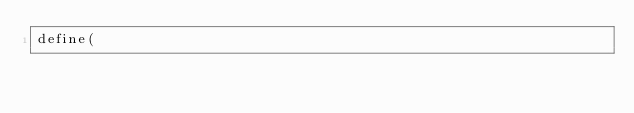<code> <loc_0><loc_0><loc_500><loc_500><_JavaScript_>define(</code> 